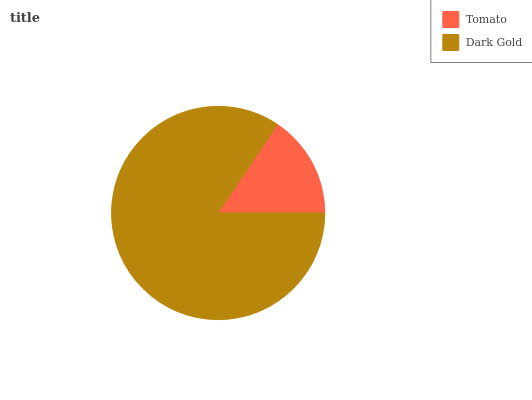Is Tomato the minimum?
Answer yes or no. Yes. Is Dark Gold the maximum?
Answer yes or no. Yes. Is Dark Gold the minimum?
Answer yes or no. No. Is Dark Gold greater than Tomato?
Answer yes or no. Yes. Is Tomato less than Dark Gold?
Answer yes or no. Yes. Is Tomato greater than Dark Gold?
Answer yes or no. No. Is Dark Gold less than Tomato?
Answer yes or no. No. Is Dark Gold the high median?
Answer yes or no. Yes. Is Tomato the low median?
Answer yes or no. Yes. Is Tomato the high median?
Answer yes or no. No. Is Dark Gold the low median?
Answer yes or no. No. 